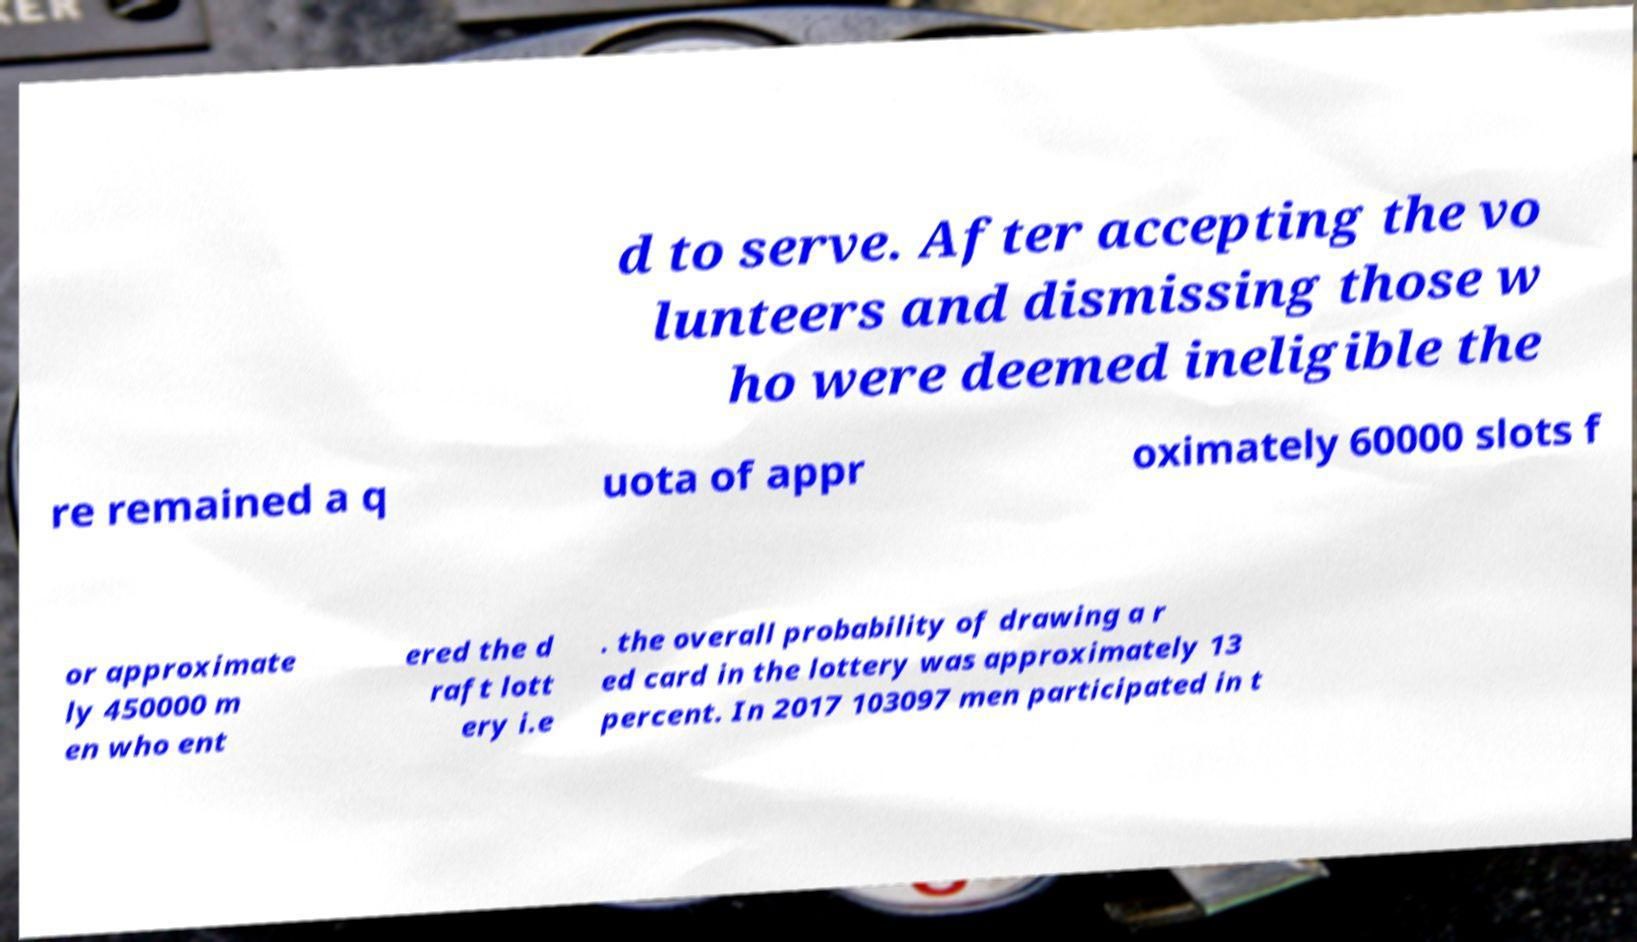Please read and relay the text visible in this image. What does it say? d to serve. After accepting the vo lunteers and dismissing those w ho were deemed ineligible the re remained a q uota of appr oximately 60000 slots f or approximate ly 450000 m en who ent ered the d raft lott ery i.e . the overall probability of drawing a r ed card in the lottery was approximately 13 percent. In 2017 103097 men participated in t 